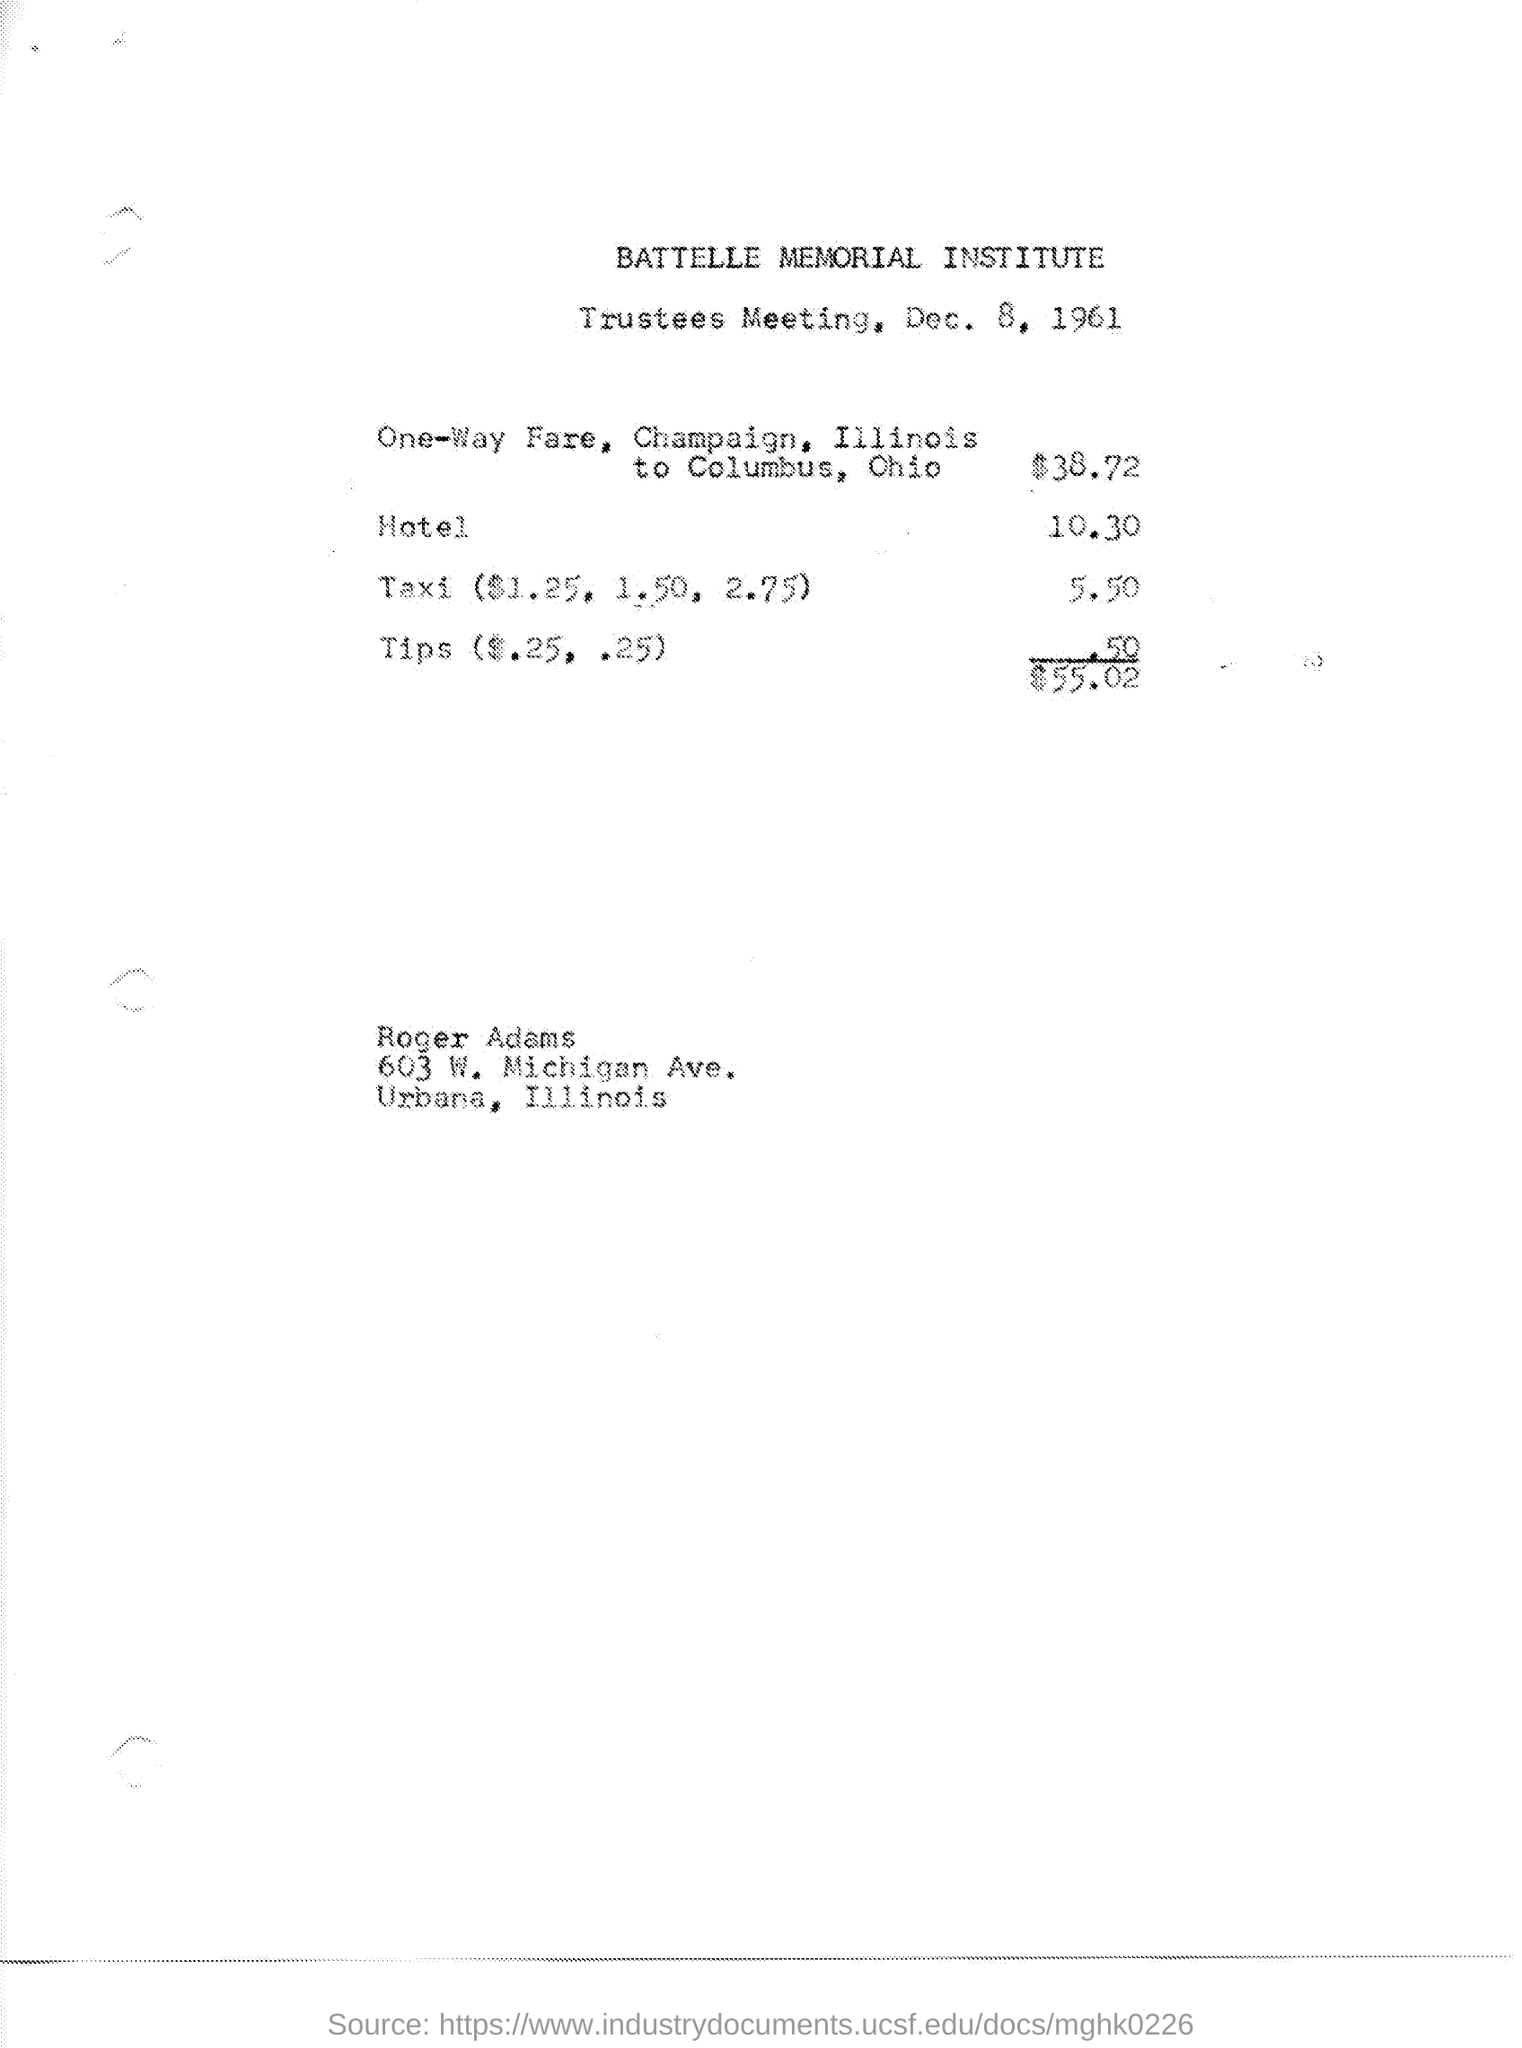Give some essential details in this illustration. The meeting is about trustees. The institute mentioned at the top of the page is Battelle Memorial Institute. The hotel fare in dollars is 10.30. The total expense is $55.02. The meeting is scheduled to take place on December 8, 1961. 